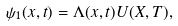<formula> <loc_0><loc_0><loc_500><loc_500>\psi _ { 1 } ( x , t ) = \Lambda ( x , t ) U ( X , T ) ,</formula> 